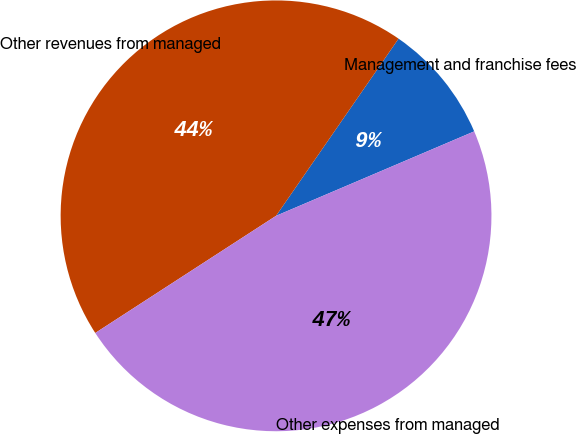Convert chart. <chart><loc_0><loc_0><loc_500><loc_500><pie_chart><fcel>Management and franchise fees<fcel>Other revenues from managed<fcel>Other expenses from managed<nl><fcel>8.96%<fcel>43.78%<fcel>47.26%<nl></chart> 